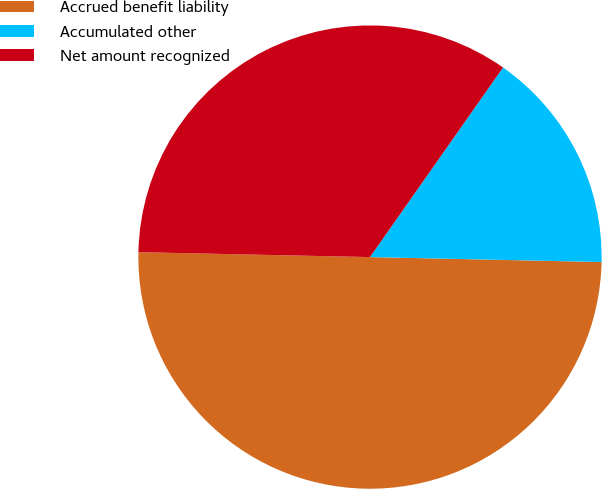Convert chart. <chart><loc_0><loc_0><loc_500><loc_500><pie_chart><fcel>Accrued benefit liability<fcel>Accumulated other<fcel>Net amount recognized<nl><fcel>50.0%<fcel>15.6%<fcel>34.4%<nl></chart> 